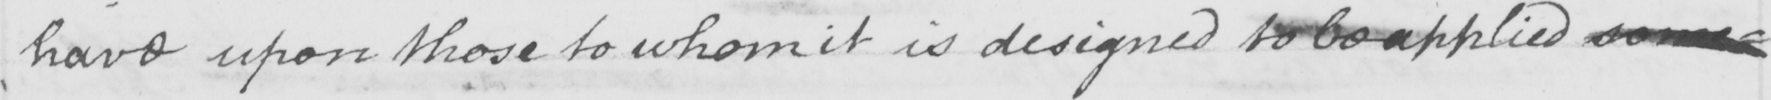What is written in this line of handwriting? have upon those to whom it is designed to be applied some= 